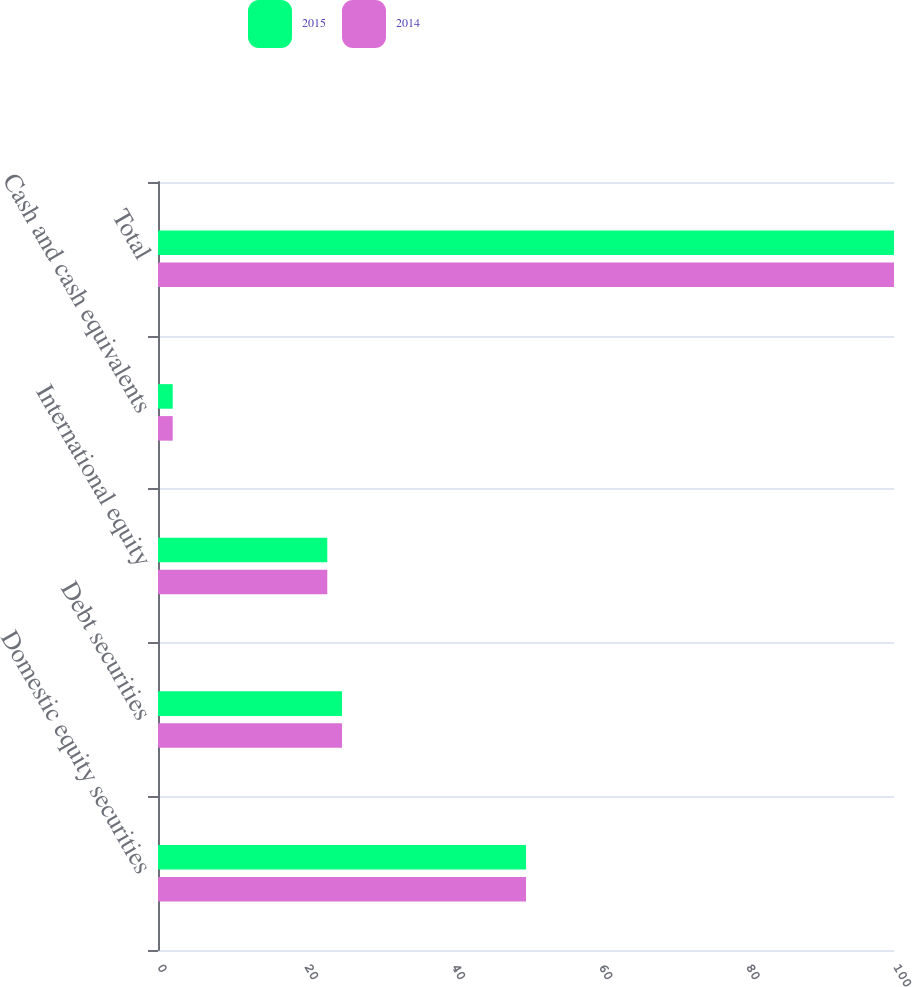Convert chart. <chart><loc_0><loc_0><loc_500><loc_500><stacked_bar_chart><ecel><fcel>Domestic equity securities<fcel>Debt securities<fcel>International equity<fcel>Cash and cash equivalents<fcel>Total<nl><fcel>2015<fcel>50<fcel>25<fcel>23<fcel>2<fcel>100<nl><fcel>2014<fcel>50<fcel>25<fcel>23<fcel>2<fcel>100<nl></chart> 